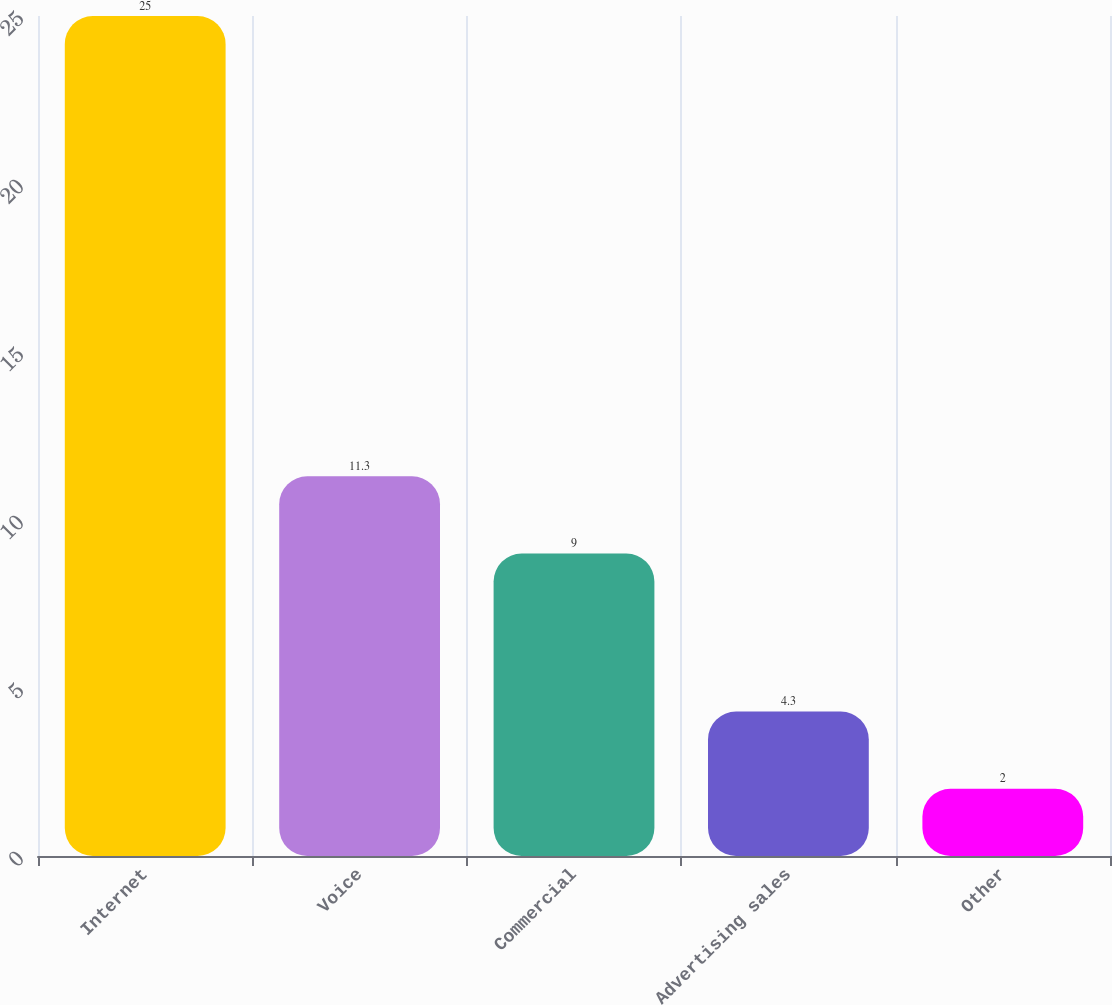Convert chart to OTSL. <chart><loc_0><loc_0><loc_500><loc_500><bar_chart><fcel>Internet<fcel>Voice<fcel>Commercial<fcel>Advertising sales<fcel>Other<nl><fcel>25<fcel>11.3<fcel>9<fcel>4.3<fcel>2<nl></chart> 